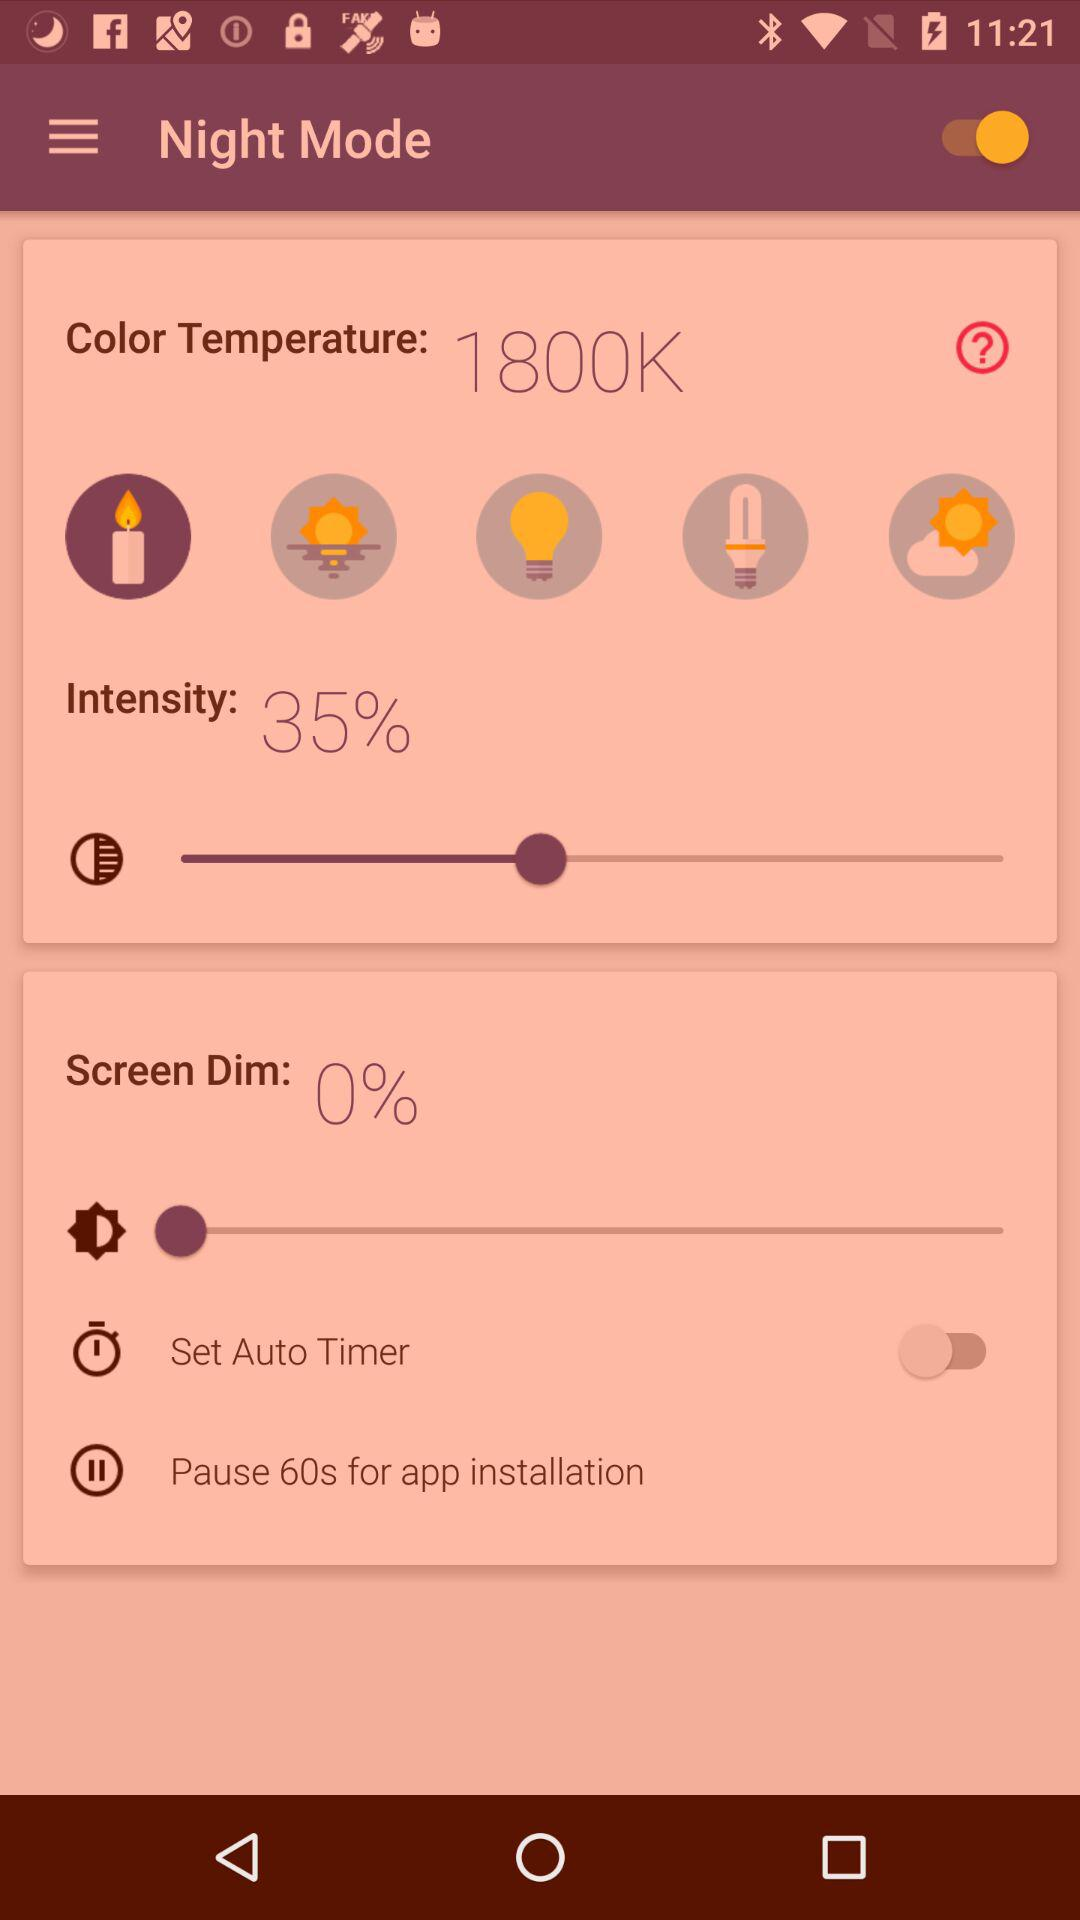Is "Pause 60s for app installation" checked or unchecked?
When the provided information is insufficient, respond with <no answer>. <no answer> 